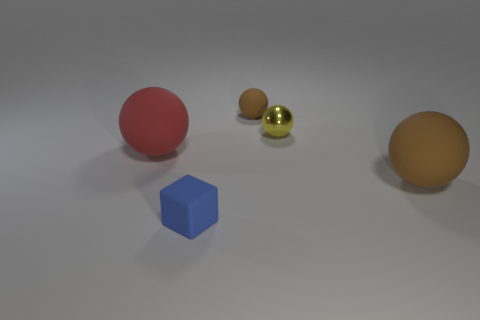Can you tell me what colors the objects in the image are? Certainly! In the image, there are five objects, each sporting a distinct hue. From the front to the back: we have a small blue cube, a large sphere dyed in a soft red, two smaller spheres—one is gold and reflective, and the other is brown with a matte finish like rubber—and lastly, a large sphere on the right that boasts an earthy brown tone. 